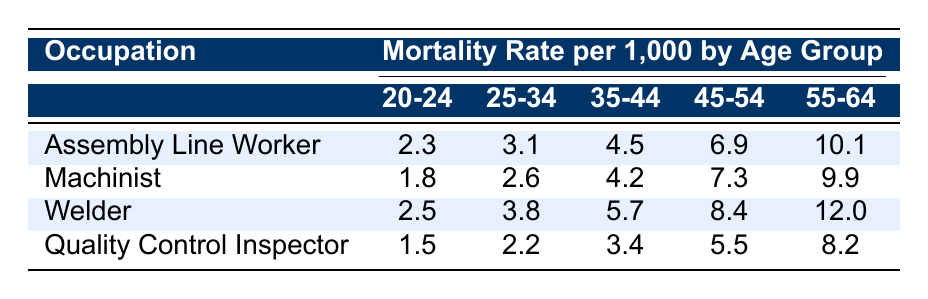What is the mortality rate for Assembly Line Workers aged 55-64? The table shows that the mortality rate for Assembly Line Workers in the age group 55-64 is 10.1 per 1000.
Answer: 10.1 Which occupation has the lowest mortality rate in the 20-24 age group? By comparing the mortality rates in the 20-24 age group for all occupations, Quality Control Inspectors have the lowest rate at 1.5 per 1000.
Answer: 1.5 What is the average mortality rate for Welders across all age groups? To calculate the average, sum the mortality rates for Welders: (2.5 + 3.8 + 5.7 + 8.4 + 12.0) = 32.4. There are 5 age groups, so the average is 32.4/5 = 6.48.
Answer: 6.48 Is the mortality rate for Machinists higher than that of Quality Control Inspectors in the 35-44 age group? The mortality rate for Machinists in the 35-44 age group is 4.2, while for Quality Control Inspectors it's 3.4. Since 4.2 is greater than 3.4, the statement is true.
Answer: Yes What is the difference in mortality rates between Assembly Line Workers and Welders in the 45-54 age group? The mortality rate for Assembly Line Workers in this age group is 6.9, and for Welders, it is 8.4. The difference is 8.4 - 6.9 = 1.5 per 1000.
Answer: 1.5 In which age group do Assembly Line Workers have the highest mortality rate? The table shows that the highest mortality rate for Assembly Line Workers is in the 55-64 age group, with a rate of 10.1 per 1000.
Answer: 55-64 How many occupations have a mortality rate higher than 9 for the 55-64 age group? Reviewing the table, Welders have a mortality rate of 12.0, and Assembly Line Workers have 10.1. Thus, there are 2 occupations (Welders and Assembly Line Workers) with a rate higher than 9.
Answer: 2 Is the mortality rate for Welders in the 25-34 age group less than 4? The mortality rate for Welders in the 25-34 age group is 3.8. Since 3.8 is less than 4, the statement is true.
Answer: Yes 